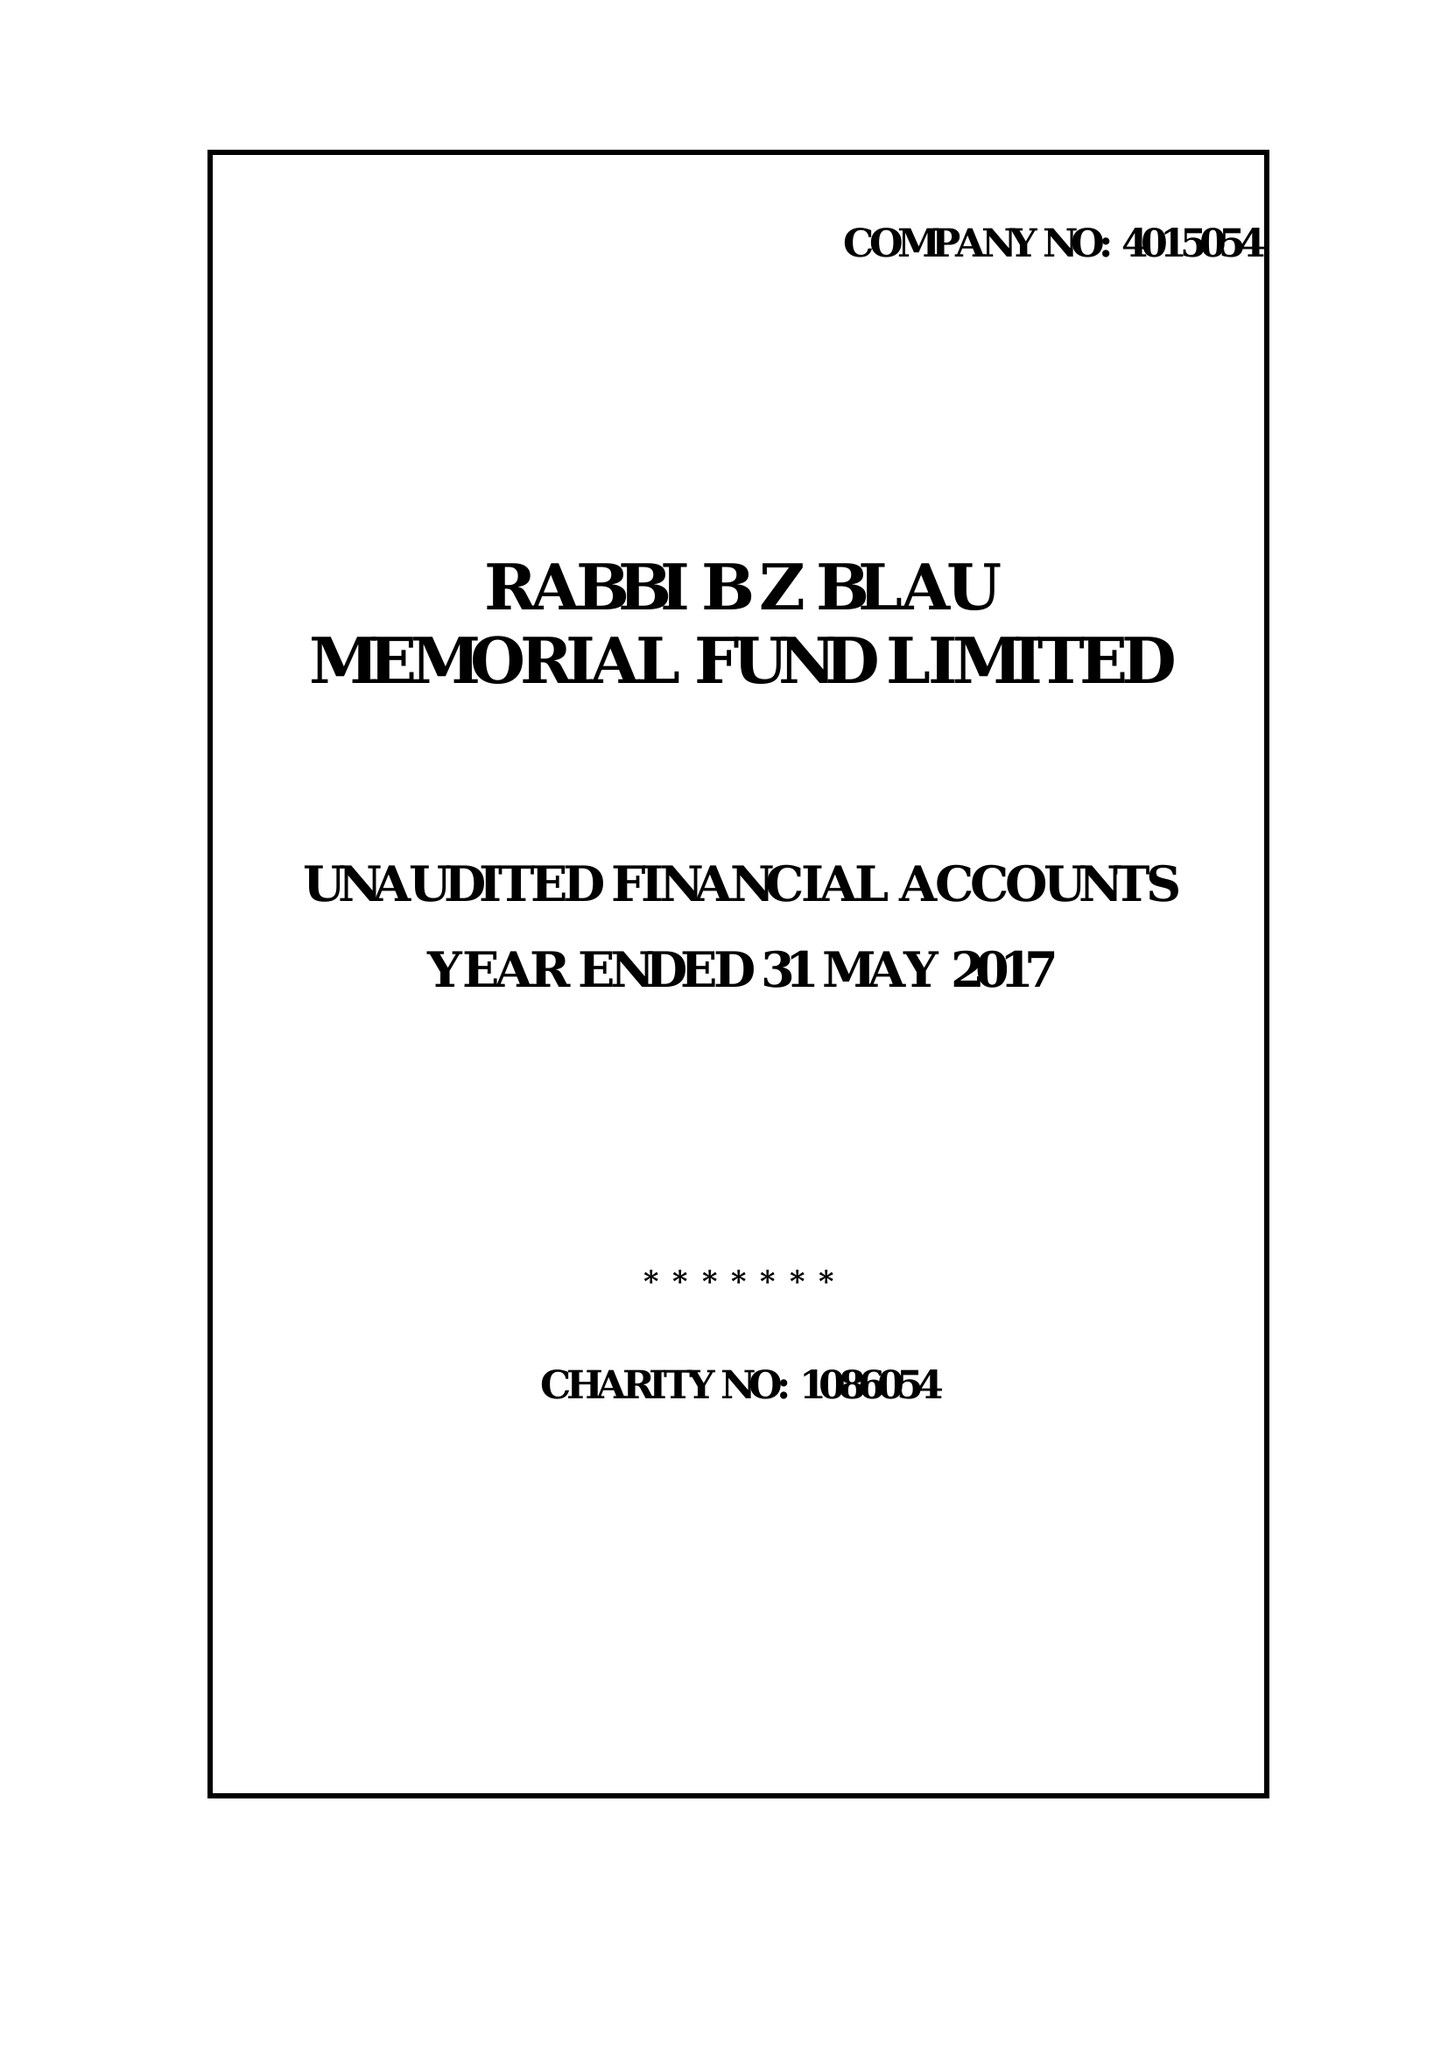What is the value for the income_annually_in_british_pounds?
Answer the question using a single word or phrase. 35013.00 